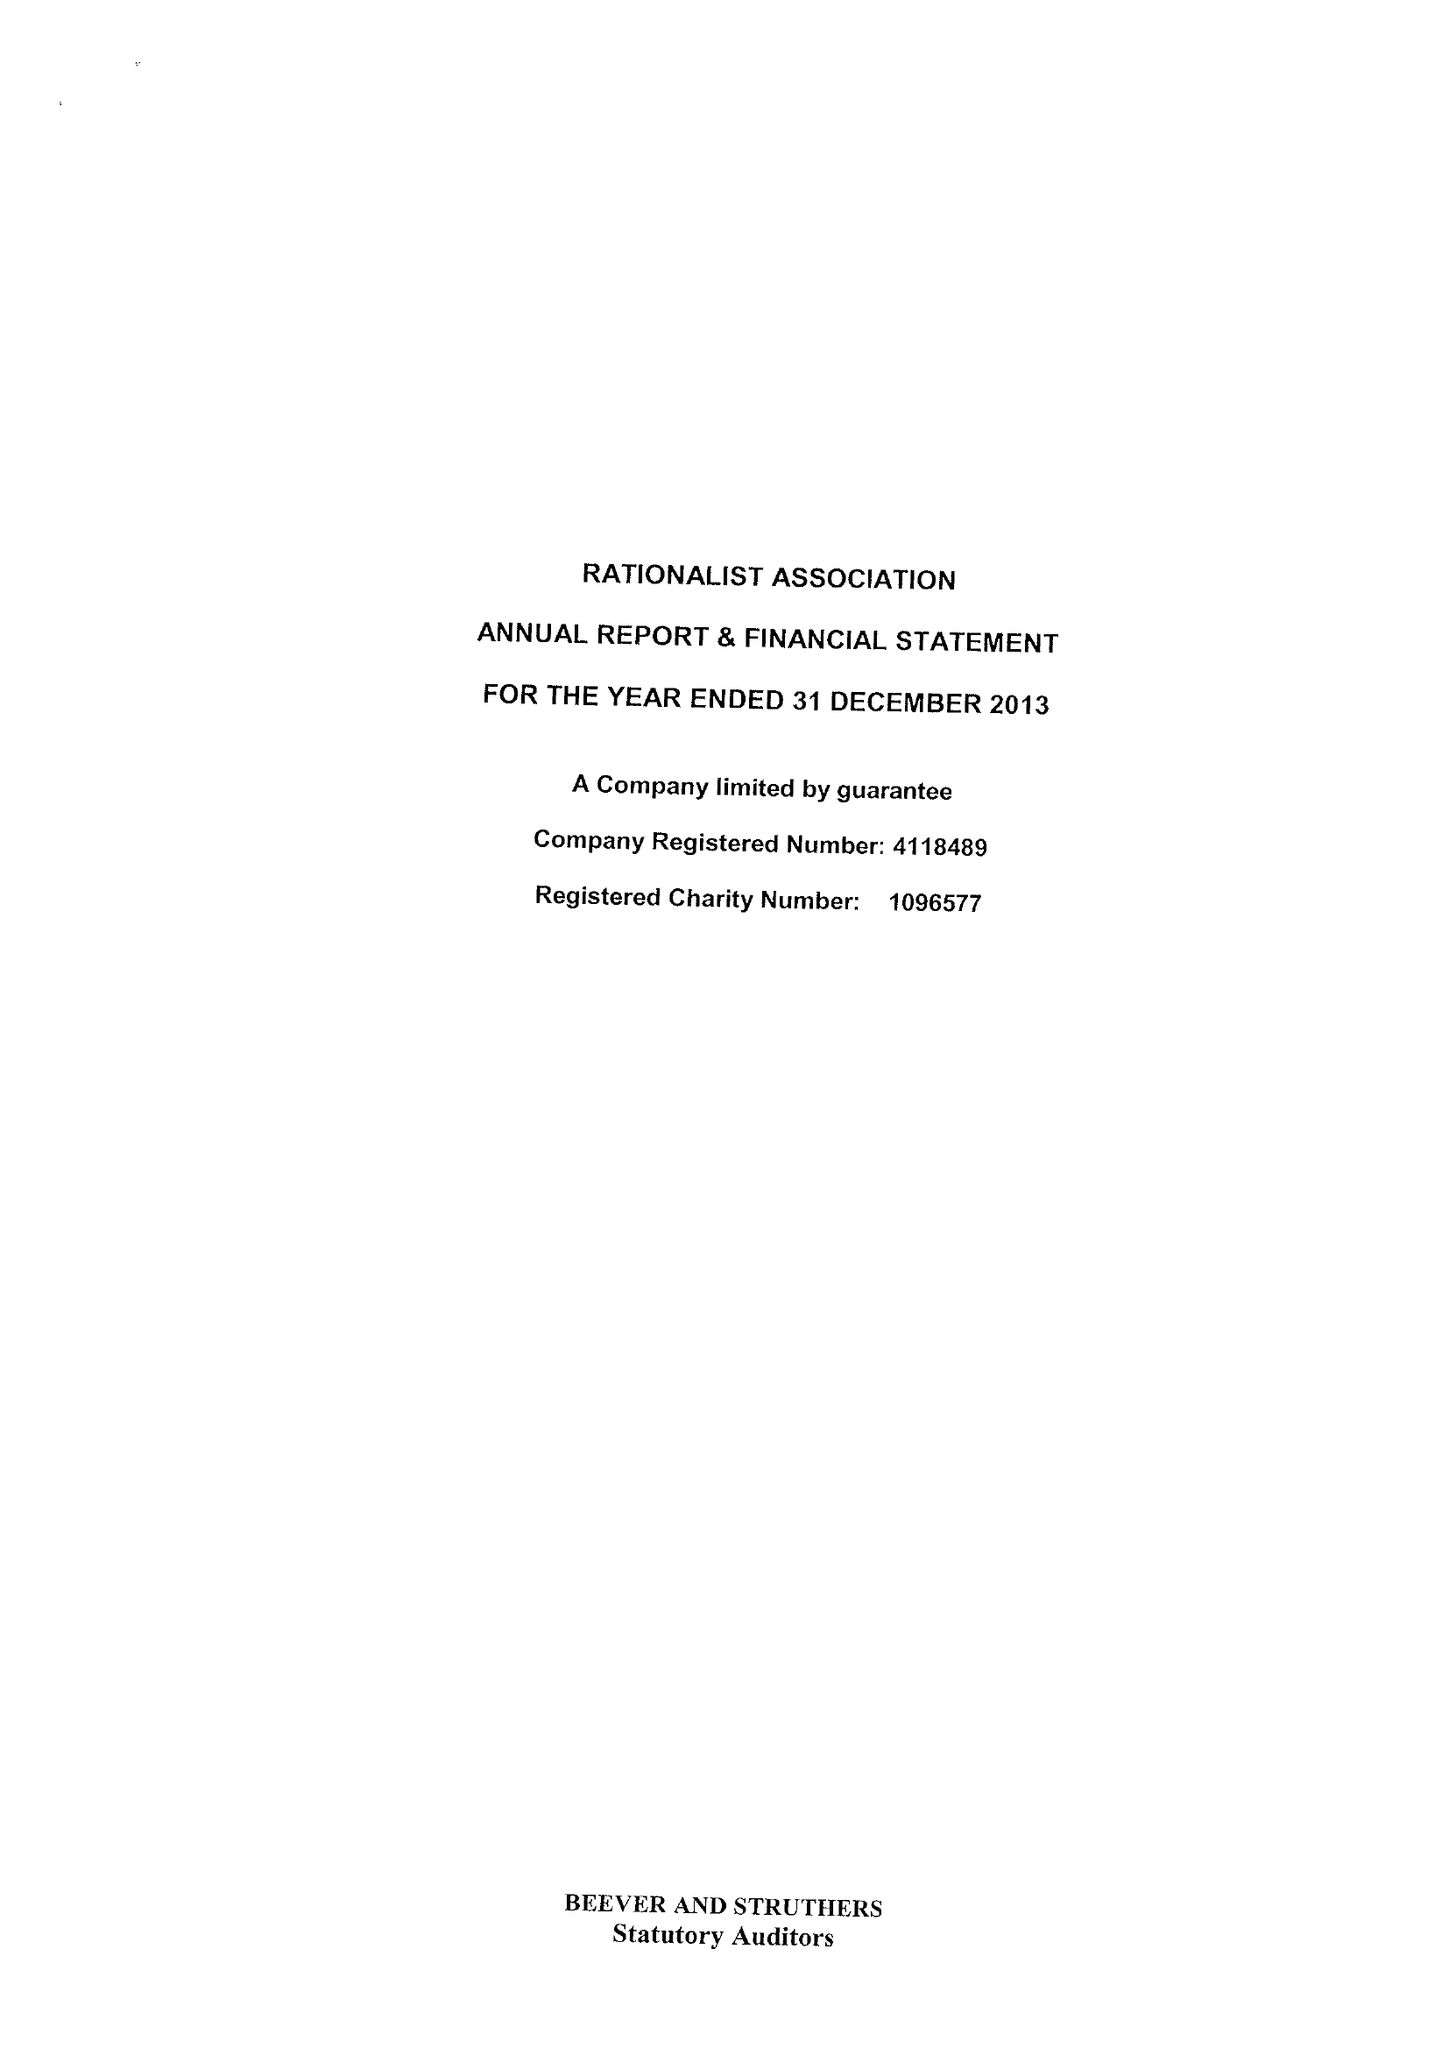What is the value for the address__street_line?
Answer the question using a single word or phrase. 244-254 CAMBRIDGE HEATH ROAD 